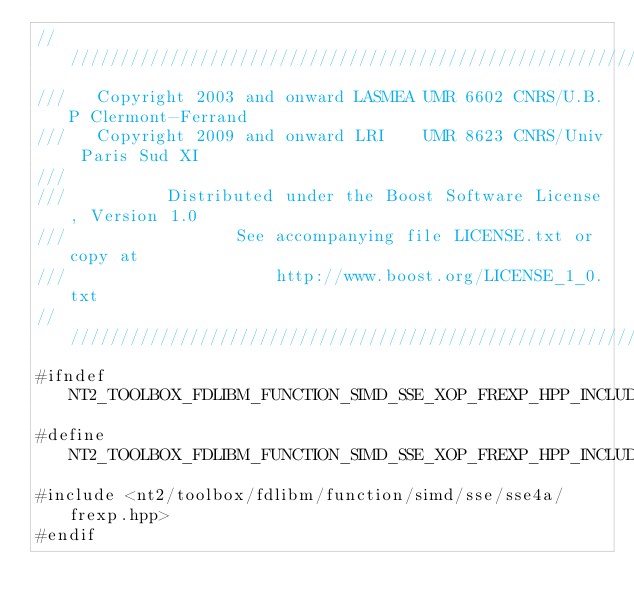<code> <loc_0><loc_0><loc_500><loc_500><_C++_>//////////////////////////////////////////////////////////////////////////////
///   Copyright 2003 and onward LASMEA UMR 6602 CNRS/U.B.P Clermont-Ferrand
///   Copyright 2009 and onward LRI    UMR 8623 CNRS/Univ Paris Sud XI
///
///          Distributed under the Boost Software License, Version 1.0
///                 See accompanying file LICENSE.txt or copy at
///                     http://www.boost.org/LICENSE_1_0.txt
//////////////////////////////////////////////////////////////////////////////
#ifndef NT2_TOOLBOX_FDLIBM_FUNCTION_SIMD_SSE_XOP_FREXP_HPP_INCLUDED
#define NT2_TOOLBOX_FDLIBM_FUNCTION_SIMD_SSE_XOP_FREXP_HPP_INCLUDED
#include <nt2/toolbox/fdlibm/function/simd/sse/sse4a/frexp.hpp>
#endif
</code> 